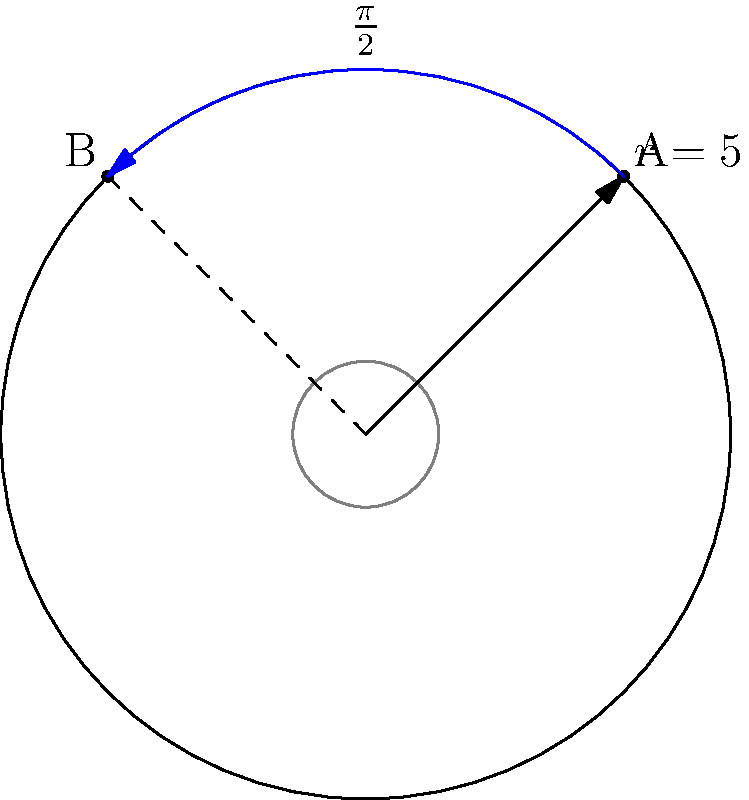In a top-down strategy game, a character needs to move from point A to point B along the circumference of a circle with radius 5 units. Given that A is at $(\frac{\pi}{4}, 5)$ and B is at $(\frac{3\pi}{4}, 5)$ in polar coordinates, what is the most efficient angular displacement (in radians) for the character's movement? To find the most efficient angular displacement, we need to follow these steps:

1. Identify the initial and final positions:
   - Point A: $(\frac{\pi}{4}, 5)$
   - Point B: $(\frac{3\pi}{4}, 5)$

2. Calculate the angular difference:
   $\Delta \theta = \theta_B - \theta_A = \frac{3\pi}{4} - \frac{\pi}{4} = \frac{\pi}{2}$

3. Consider the symmetry of the circle:
   - The character can move clockwise or counterclockwise.
   - The shorter arc is always less than or equal to $\pi$ radians.

4. Compare the calculated $\Delta \theta$ with $\pi$:
   $\frac{\pi}{2} < \pi$

5. Conclusion:
   The calculated $\Delta \theta$ represents the shorter arc, so it is the most efficient angular displacement.
Answer: $\frac{\pi}{2}$ radians 